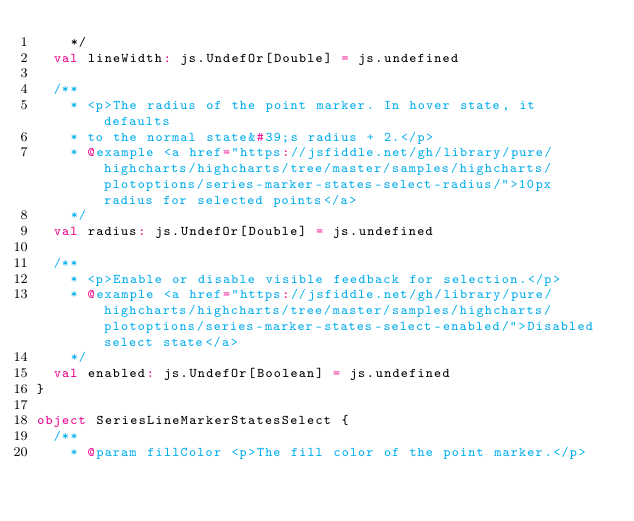<code> <loc_0><loc_0><loc_500><loc_500><_Scala_>    */
  val lineWidth: js.UndefOr[Double] = js.undefined

  /**
    * <p>The radius of the point marker. In hover state, it defaults
    * to the normal state&#39;s radius + 2.</p>
    * @example <a href="https://jsfiddle.net/gh/library/pure/highcharts/highcharts/tree/master/samples/highcharts/plotoptions/series-marker-states-select-radius/">10px radius for selected points</a>
    */
  val radius: js.UndefOr[Double] = js.undefined

  /**
    * <p>Enable or disable visible feedback for selection.</p>
    * @example <a href="https://jsfiddle.net/gh/library/pure/highcharts/highcharts/tree/master/samples/highcharts/plotoptions/series-marker-states-select-enabled/">Disabled select state</a>
    */
  val enabled: js.UndefOr[Boolean] = js.undefined
}

object SeriesLineMarkerStatesSelect {
  /**
    * @param fillColor <p>The fill color of the point marker.</p></code> 